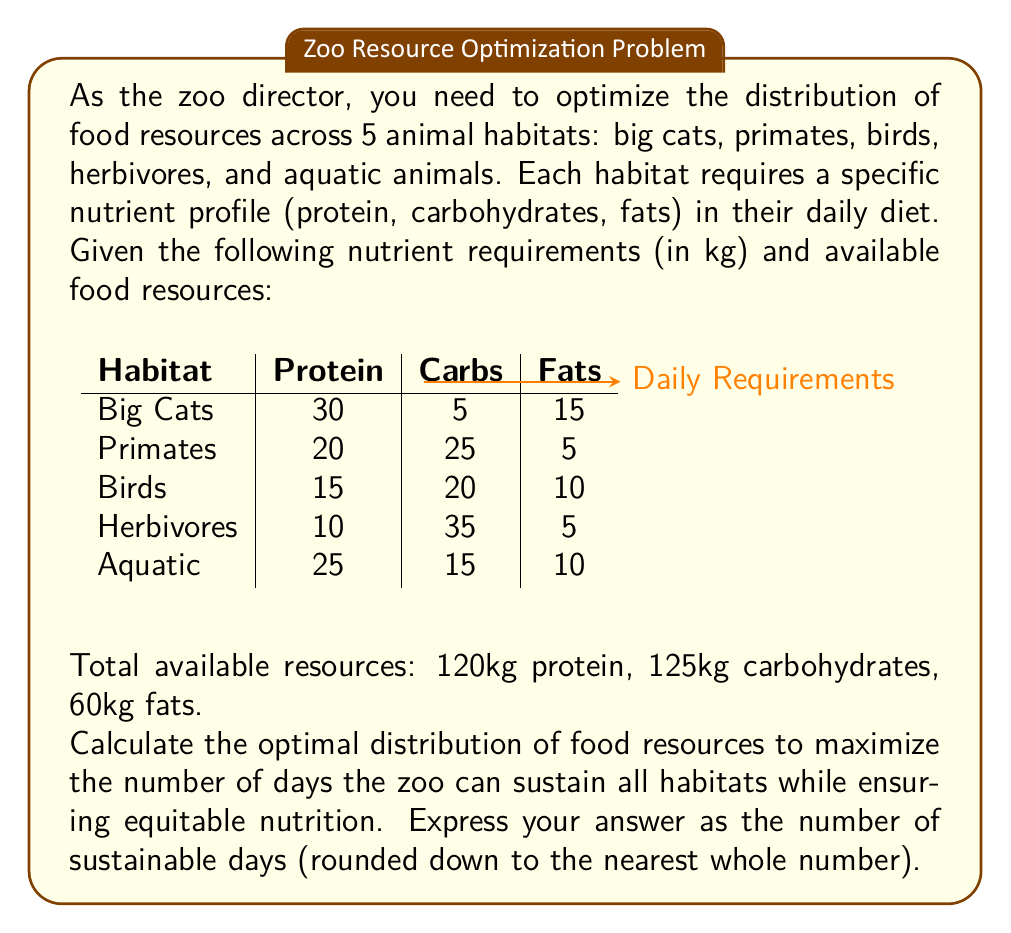Show me your answer to this math problem. To solve this problem, we need to use linear programming techniques from functional analysis. Let's approach this step-by-step:

1) Let $x$ be the number of days we can sustain all habitats.

2) For each nutrient, the total amount used across all habitats for $x$ days must not exceed the available resources:

   Protein: $x(30 + 20 + 15 + 10 + 25) \leq 120$
   Carbs: $x(5 + 25 + 20 + 35 + 15) \leq 125$
   Fats: $x(15 + 5 + 10 + 5 + 10) \leq 60$

3) Simplify these inequalities:

   $100x \leq 120$
   $100x \leq 125$
   $45x \leq 60$

4) To maximize $x$, we need to find the most restrictive inequality. Divide the right side by the coefficient of $x$ for each:

   $x \leq 1.2$ (from protein)
   $x \leq 1.25$ (from carbs)
   $x \leq 1.33$ (from fats)

5) The most restrictive is $x \leq 1.2$, coming from the protein constraint.

6) Since we need to round down to the nearest whole number, the maximum number of sustainable days is 1.

This solution ensures equitable nutrition as it provides each habitat with exactly the nutrient profile they require, without favoring any particular habitat over the others.
Answer: 1 day 